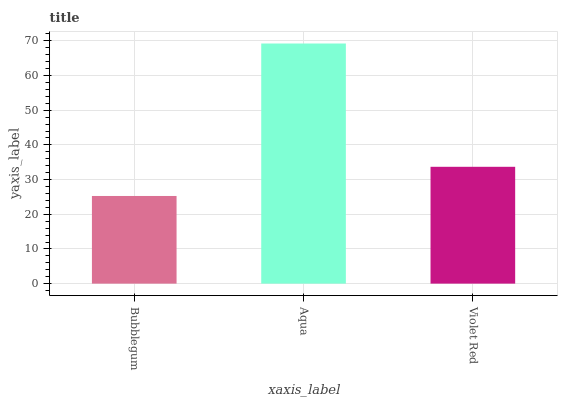Is Bubblegum the minimum?
Answer yes or no. Yes. Is Aqua the maximum?
Answer yes or no. Yes. Is Violet Red the minimum?
Answer yes or no. No. Is Violet Red the maximum?
Answer yes or no. No. Is Aqua greater than Violet Red?
Answer yes or no. Yes. Is Violet Red less than Aqua?
Answer yes or no. Yes. Is Violet Red greater than Aqua?
Answer yes or no. No. Is Aqua less than Violet Red?
Answer yes or no. No. Is Violet Red the high median?
Answer yes or no. Yes. Is Violet Red the low median?
Answer yes or no. Yes. Is Aqua the high median?
Answer yes or no. No. Is Bubblegum the low median?
Answer yes or no. No. 